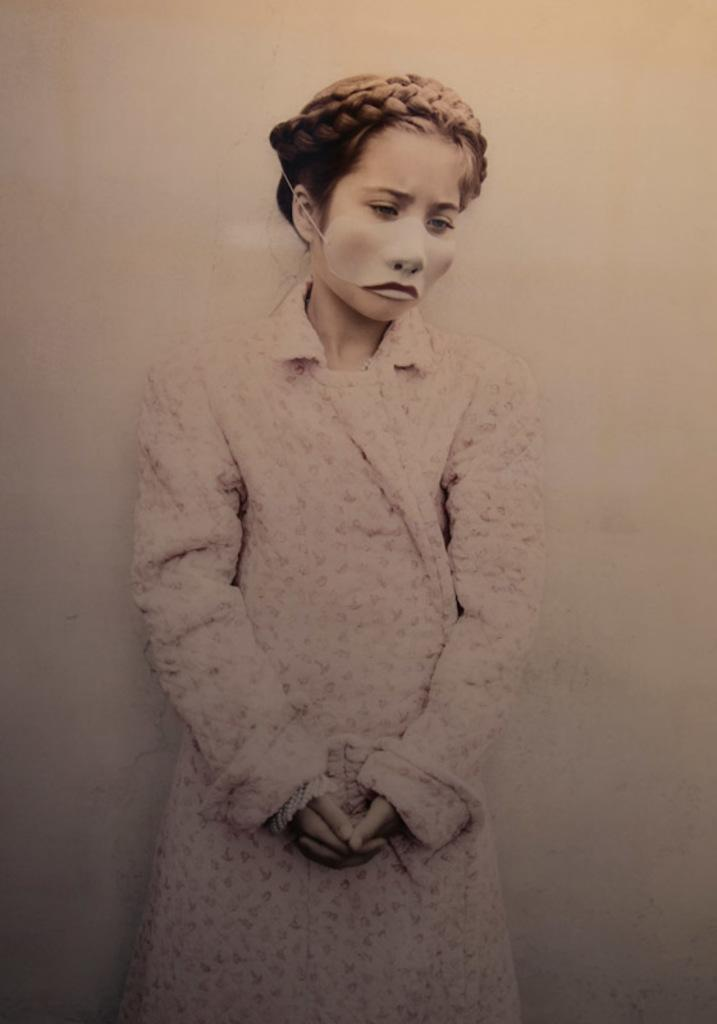Who is the main subject in the foreground of the image? There is a woman in the foreground of the image. What is the woman doing in the image? The woman is standing. What is the woman wearing on her face in the image? The woman is wearing a face mask. What can be seen in the background of the image? There is a wall in the image. How many songs can be heard playing in the background of the image? There is no information about songs or music in the image, so it cannot be determined. 